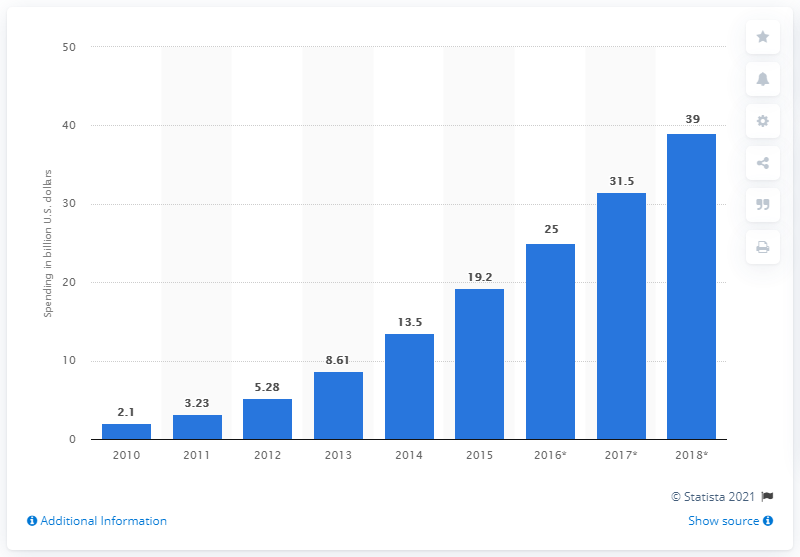Indicate a few pertinent items in this graphic. In 2014, the United States spent approximately $13.5 billion on intelligent transportation systems. 